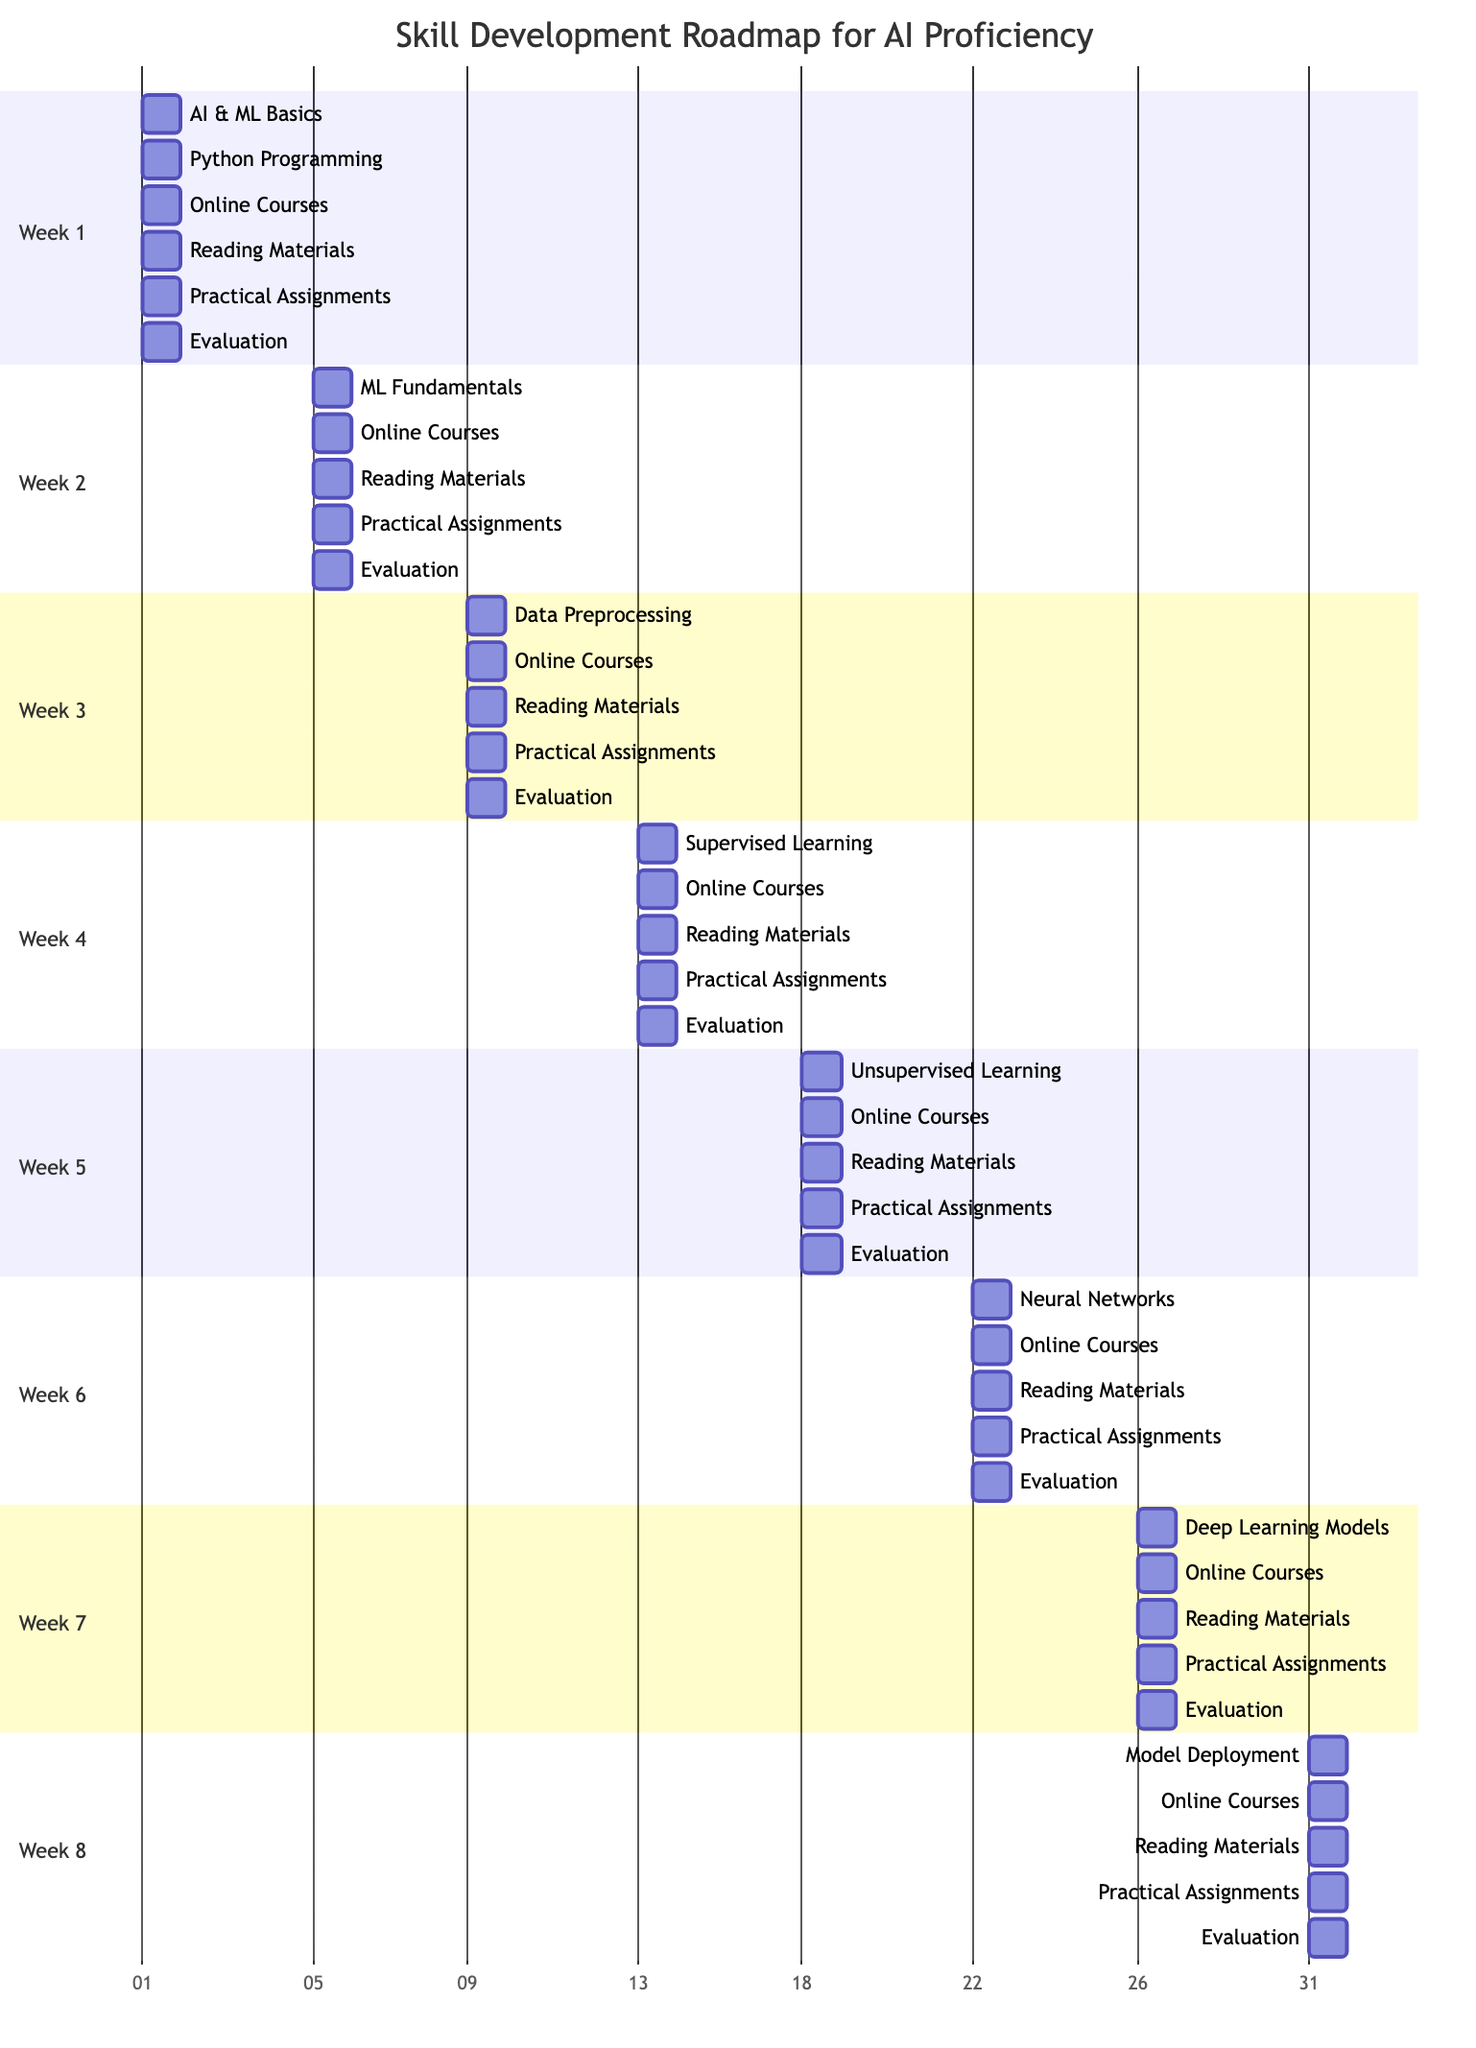What are the learning objectives for week 4? Week 4 contains a section indicating the learning objectives, which includes "Delve into supervised learning models". This is directly listed under the week 4 section of the Gantt chart.
Answer: Delve into supervised learning models Which online course is associated with week 5? The week 5 section specifically lists "Unsupervised Learning (Udacity)" as the online course to be taken during that week.
Answer: Unsupervised Learning (Udacity) How many practical assignments are there in total across all weeks? Each week lists one practical assignment. There are 8 weeks, thus the total number of practical assignments is 8. This can be confirmed by totaling the assignments listed in each week.
Answer: 8 For which week is the reading material "Deep Learning by Ian Goodfellow, Yoshua Bengio, and Aaron Courville" assigned? According to the week 5 section, the reading material "Deep Learning by Ian Goodfellow, Yoshua Bengio, and Aaron Courville" is assigned specifically for that week, indicating its relevance to the unsupervised learning topic.
Answer: Week 5 What is the evaluation checkpoint for week 6? Week 6 includes two evaluation checkpoints: "Complete graded assignments in the course" and "Submit code for review". It highlights the evaluation structure for that week.
Answer: Complete graded assignments in the course Which practical assignment is scheduled for week 2? The week 2 section mentions "Implement basic machine learning algorithms using Scikit-Learn" as the designated practical assignment for that week.
Answer: Implement basic machine learning algorithms using Scikit-Learn What is the main focus of week 7? The week 7 section expresses that the focus is on "Implement and tune deep learning models", which guides the learning for that week.
Answer: Implement and tune deep learning models What type of learning is primarily covered in week 3? In week 3, the section points out the focus on "Explore data preprocessing techniques", indicating the primary learning topic for that week.
Answer: Explore data preprocessing techniques 